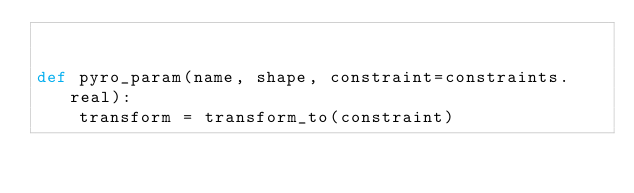Convert code to text. <code><loc_0><loc_0><loc_500><loc_500><_Python_>

def pyro_param(name, shape, constraint=constraints.real):
    transform = transform_to(constraint)</code> 